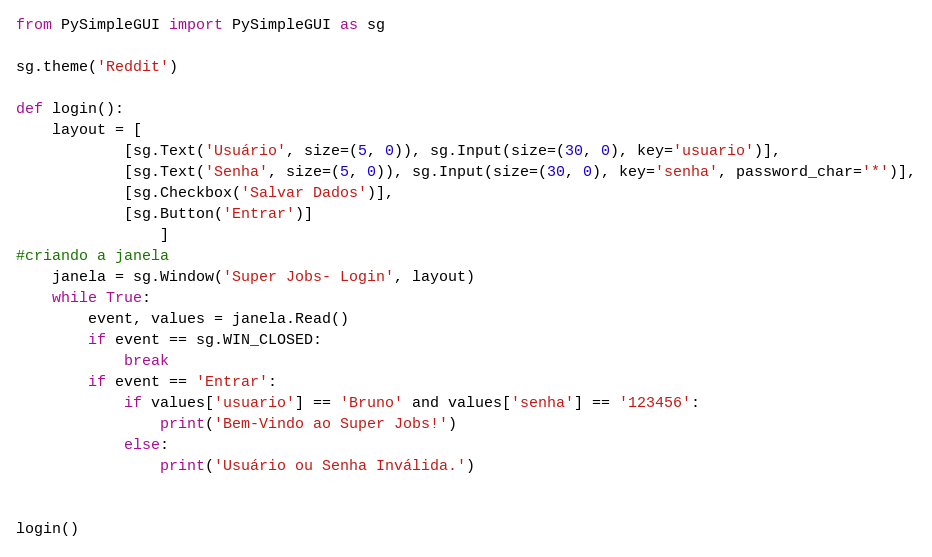Convert code to text. <code><loc_0><loc_0><loc_500><loc_500><_Python_>from PySimpleGUI import PySimpleGUI as sg

sg.theme('Reddit')

def login():
    layout = [
            [sg.Text('Usuário', size=(5, 0)), sg.Input(size=(30, 0), key='usuario')],
            [sg.Text('Senha', size=(5, 0)), sg.Input(size=(30, 0), key='senha', password_char='*')],
            [sg.Checkbox('Salvar Dados')],
            [sg.Button('Entrar')]
                ]
#criando a janela
    janela = sg.Window('Super Jobs- Login', layout)
    while True:
        event, values = janela.Read()
        if event == sg.WIN_CLOSED:
            break
        if event == 'Entrar':
            if values['usuario'] == 'Bruno' and values['senha'] == '123456':
                print('Bem-Vindo ao Super Jobs!')
            else:
                print('Usuário ou Senha Inválida.')


login()
</code> 